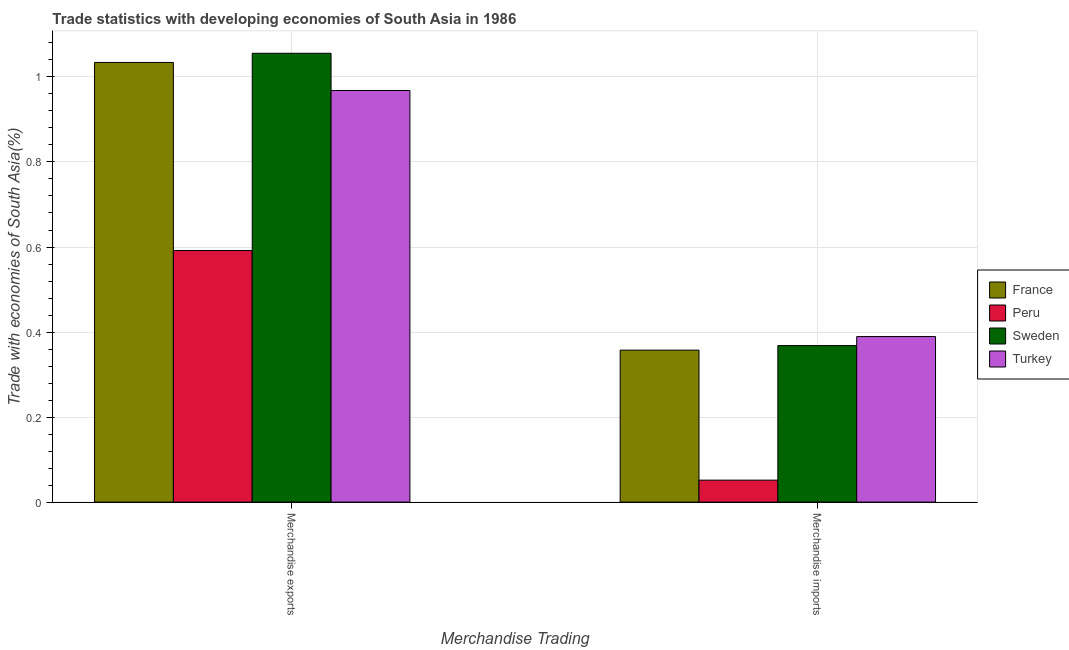How many groups of bars are there?
Your answer should be compact. 2. Are the number of bars per tick equal to the number of legend labels?
Give a very brief answer. Yes. How many bars are there on the 2nd tick from the left?
Ensure brevity in your answer.  4. How many bars are there on the 1st tick from the right?
Keep it short and to the point. 4. What is the merchandise exports in Turkey?
Make the answer very short. 0.97. Across all countries, what is the maximum merchandise exports?
Give a very brief answer. 1.06. Across all countries, what is the minimum merchandise exports?
Your answer should be compact. 0.59. In which country was the merchandise imports maximum?
Offer a terse response. Turkey. In which country was the merchandise exports minimum?
Your answer should be compact. Peru. What is the total merchandise exports in the graph?
Your response must be concise. 3.65. What is the difference between the merchandise imports in France and that in Turkey?
Your response must be concise. -0.03. What is the difference between the merchandise imports in Sweden and the merchandise exports in Turkey?
Provide a short and direct response. -0.6. What is the average merchandise imports per country?
Offer a very short reply. 0.29. What is the difference between the merchandise imports and merchandise exports in Turkey?
Offer a terse response. -0.58. In how many countries, is the merchandise exports greater than 0.12 %?
Offer a terse response. 4. What is the ratio of the merchandise exports in Sweden to that in France?
Your response must be concise. 1.02. In how many countries, is the merchandise exports greater than the average merchandise exports taken over all countries?
Offer a terse response. 3. What does the 2nd bar from the left in Merchandise imports represents?
Make the answer very short. Peru. What does the 4th bar from the right in Merchandise exports represents?
Offer a very short reply. France. How many countries are there in the graph?
Offer a terse response. 4. Does the graph contain any zero values?
Offer a terse response. No. How many legend labels are there?
Your answer should be compact. 4. What is the title of the graph?
Ensure brevity in your answer.  Trade statistics with developing economies of South Asia in 1986. Does "World" appear as one of the legend labels in the graph?
Provide a short and direct response. No. What is the label or title of the X-axis?
Your answer should be compact. Merchandise Trading. What is the label or title of the Y-axis?
Your answer should be compact. Trade with economies of South Asia(%). What is the Trade with economies of South Asia(%) of France in Merchandise exports?
Make the answer very short. 1.03. What is the Trade with economies of South Asia(%) of Peru in Merchandise exports?
Your answer should be very brief. 0.59. What is the Trade with economies of South Asia(%) of Sweden in Merchandise exports?
Keep it short and to the point. 1.06. What is the Trade with economies of South Asia(%) in Turkey in Merchandise exports?
Make the answer very short. 0.97. What is the Trade with economies of South Asia(%) of France in Merchandise imports?
Your answer should be very brief. 0.36. What is the Trade with economies of South Asia(%) of Peru in Merchandise imports?
Your answer should be very brief. 0.05. What is the Trade with economies of South Asia(%) in Sweden in Merchandise imports?
Give a very brief answer. 0.37. What is the Trade with economies of South Asia(%) of Turkey in Merchandise imports?
Ensure brevity in your answer.  0.39. Across all Merchandise Trading, what is the maximum Trade with economies of South Asia(%) of France?
Offer a terse response. 1.03. Across all Merchandise Trading, what is the maximum Trade with economies of South Asia(%) in Peru?
Offer a terse response. 0.59. Across all Merchandise Trading, what is the maximum Trade with economies of South Asia(%) in Sweden?
Ensure brevity in your answer.  1.06. Across all Merchandise Trading, what is the maximum Trade with economies of South Asia(%) of Turkey?
Your answer should be very brief. 0.97. Across all Merchandise Trading, what is the minimum Trade with economies of South Asia(%) in France?
Provide a short and direct response. 0.36. Across all Merchandise Trading, what is the minimum Trade with economies of South Asia(%) in Peru?
Provide a succinct answer. 0.05. Across all Merchandise Trading, what is the minimum Trade with economies of South Asia(%) in Sweden?
Ensure brevity in your answer.  0.37. Across all Merchandise Trading, what is the minimum Trade with economies of South Asia(%) in Turkey?
Provide a short and direct response. 0.39. What is the total Trade with economies of South Asia(%) of France in the graph?
Give a very brief answer. 1.39. What is the total Trade with economies of South Asia(%) of Peru in the graph?
Keep it short and to the point. 0.64. What is the total Trade with economies of South Asia(%) in Sweden in the graph?
Keep it short and to the point. 1.42. What is the total Trade with economies of South Asia(%) of Turkey in the graph?
Provide a succinct answer. 1.36. What is the difference between the Trade with economies of South Asia(%) of France in Merchandise exports and that in Merchandise imports?
Offer a very short reply. 0.68. What is the difference between the Trade with economies of South Asia(%) of Peru in Merchandise exports and that in Merchandise imports?
Provide a short and direct response. 0.54. What is the difference between the Trade with economies of South Asia(%) of Sweden in Merchandise exports and that in Merchandise imports?
Keep it short and to the point. 0.69. What is the difference between the Trade with economies of South Asia(%) in Turkey in Merchandise exports and that in Merchandise imports?
Provide a short and direct response. 0.58. What is the difference between the Trade with economies of South Asia(%) of France in Merchandise exports and the Trade with economies of South Asia(%) of Peru in Merchandise imports?
Offer a very short reply. 0.98. What is the difference between the Trade with economies of South Asia(%) of France in Merchandise exports and the Trade with economies of South Asia(%) of Sweden in Merchandise imports?
Offer a terse response. 0.67. What is the difference between the Trade with economies of South Asia(%) in France in Merchandise exports and the Trade with economies of South Asia(%) in Turkey in Merchandise imports?
Your response must be concise. 0.64. What is the difference between the Trade with economies of South Asia(%) of Peru in Merchandise exports and the Trade with economies of South Asia(%) of Sweden in Merchandise imports?
Your response must be concise. 0.22. What is the difference between the Trade with economies of South Asia(%) in Peru in Merchandise exports and the Trade with economies of South Asia(%) in Turkey in Merchandise imports?
Ensure brevity in your answer.  0.2. What is the difference between the Trade with economies of South Asia(%) in Sweden in Merchandise exports and the Trade with economies of South Asia(%) in Turkey in Merchandise imports?
Keep it short and to the point. 0.67. What is the average Trade with economies of South Asia(%) in France per Merchandise Trading?
Provide a short and direct response. 0.7. What is the average Trade with economies of South Asia(%) of Peru per Merchandise Trading?
Provide a succinct answer. 0.32. What is the average Trade with economies of South Asia(%) of Sweden per Merchandise Trading?
Ensure brevity in your answer.  0.71. What is the average Trade with economies of South Asia(%) in Turkey per Merchandise Trading?
Give a very brief answer. 0.68. What is the difference between the Trade with economies of South Asia(%) of France and Trade with economies of South Asia(%) of Peru in Merchandise exports?
Provide a succinct answer. 0.44. What is the difference between the Trade with economies of South Asia(%) of France and Trade with economies of South Asia(%) of Sweden in Merchandise exports?
Offer a terse response. -0.02. What is the difference between the Trade with economies of South Asia(%) of France and Trade with economies of South Asia(%) of Turkey in Merchandise exports?
Ensure brevity in your answer.  0.07. What is the difference between the Trade with economies of South Asia(%) of Peru and Trade with economies of South Asia(%) of Sweden in Merchandise exports?
Give a very brief answer. -0.46. What is the difference between the Trade with economies of South Asia(%) in Peru and Trade with economies of South Asia(%) in Turkey in Merchandise exports?
Provide a succinct answer. -0.38. What is the difference between the Trade with economies of South Asia(%) of Sweden and Trade with economies of South Asia(%) of Turkey in Merchandise exports?
Your answer should be very brief. 0.09. What is the difference between the Trade with economies of South Asia(%) of France and Trade with economies of South Asia(%) of Peru in Merchandise imports?
Make the answer very short. 0.31. What is the difference between the Trade with economies of South Asia(%) of France and Trade with economies of South Asia(%) of Sweden in Merchandise imports?
Ensure brevity in your answer.  -0.01. What is the difference between the Trade with economies of South Asia(%) of France and Trade with economies of South Asia(%) of Turkey in Merchandise imports?
Ensure brevity in your answer.  -0.03. What is the difference between the Trade with economies of South Asia(%) in Peru and Trade with economies of South Asia(%) in Sweden in Merchandise imports?
Keep it short and to the point. -0.32. What is the difference between the Trade with economies of South Asia(%) of Peru and Trade with economies of South Asia(%) of Turkey in Merchandise imports?
Ensure brevity in your answer.  -0.34. What is the difference between the Trade with economies of South Asia(%) of Sweden and Trade with economies of South Asia(%) of Turkey in Merchandise imports?
Offer a very short reply. -0.02. What is the ratio of the Trade with economies of South Asia(%) of France in Merchandise exports to that in Merchandise imports?
Offer a terse response. 2.89. What is the ratio of the Trade with economies of South Asia(%) in Peru in Merchandise exports to that in Merchandise imports?
Keep it short and to the point. 11.45. What is the ratio of the Trade with economies of South Asia(%) in Sweden in Merchandise exports to that in Merchandise imports?
Provide a short and direct response. 2.87. What is the ratio of the Trade with economies of South Asia(%) in Turkey in Merchandise exports to that in Merchandise imports?
Make the answer very short. 2.49. What is the difference between the highest and the second highest Trade with economies of South Asia(%) of France?
Your response must be concise. 0.68. What is the difference between the highest and the second highest Trade with economies of South Asia(%) in Peru?
Offer a terse response. 0.54. What is the difference between the highest and the second highest Trade with economies of South Asia(%) of Sweden?
Provide a succinct answer. 0.69. What is the difference between the highest and the second highest Trade with economies of South Asia(%) of Turkey?
Your answer should be compact. 0.58. What is the difference between the highest and the lowest Trade with economies of South Asia(%) of France?
Offer a terse response. 0.68. What is the difference between the highest and the lowest Trade with economies of South Asia(%) of Peru?
Keep it short and to the point. 0.54. What is the difference between the highest and the lowest Trade with economies of South Asia(%) in Sweden?
Your answer should be very brief. 0.69. What is the difference between the highest and the lowest Trade with economies of South Asia(%) of Turkey?
Offer a terse response. 0.58. 